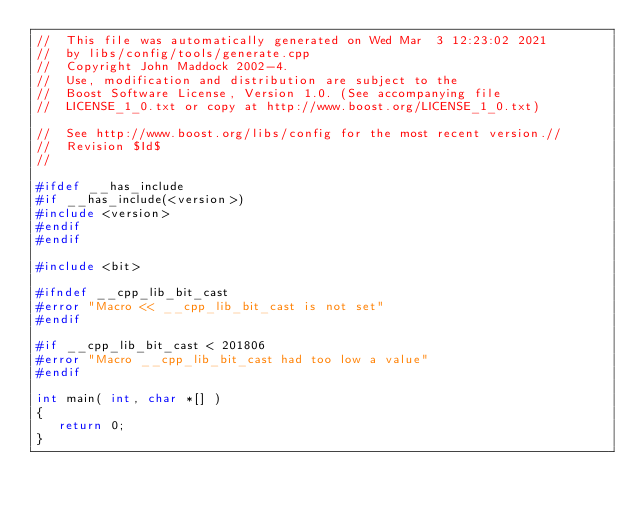<code> <loc_0><loc_0><loc_500><loc_500><_C++_>//  This file was automatically generated on Wed Mar  3 12:23:02 2021
//  by libs/config/tools/generate.cpp
//  Copyright John Maddock 2002-4.
//  Use, modification and distribution are subject to the 
//  Boost Software License, Version 1.0. (See accompanying file 
//  LICENSE_1_0.txt or copy at http://www.boost.org/LICENSE_1_0.txt)

//  See http://www.boost.org/libs/config for the most recent version.//
//  Revision $Id$
//

#ifdef __has_include
#if __has_include(<version>)
#include <version>
#endif
#endif

#include <bit>

#ifndef __cpp_lib_bit_cast
#error "Macro << __cpp_lib_bit_cast is not set"
#endif

#if __cpp_lib_bit_cast < 201806
#error "Macro __cpp_lib_bit_cast had too low a value"
#endif

int main( int, char *[] )
{
   return 0;
}

</code> 